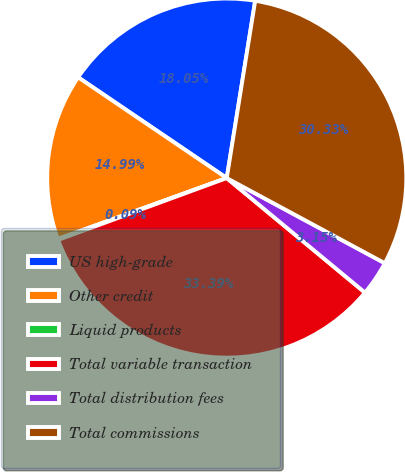Convert chart. <chart><loc_0><loc_0><loc_500><loc_500><pie_chart><fcel>US high-grade<fcel>Other credit<fcel>Liquid products<fcel>Total variable transaction<fcel>Total distribution fees<fcel>Total commissions<nl><fcel>18.05%<fcel>14.99%<fcel>0.09%<fcel>33.39%<fcel>3.15%<fcel>30.33%<nl></chart> 